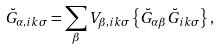<formula> <loc_0><loc_0><loc_500><loc_500>\breve { G } _ { \alpha , i k \sigma } = \sum _ { \beta } V _ { \beta , i k \sigma } \left \{ \breve { G } _ { \alpha \beta } \breve { G } _ { i k \sigma } \right \} ,</formula> 